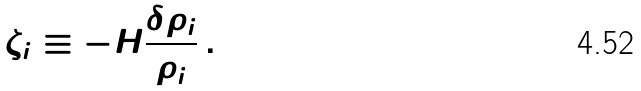Convert formula to latex. <formula><loc_0><loc_0><loc_500><loc_500>\zeta _ { i } \equiv - H \frac { \delta \rho _ { i } } { \dot { \rho } _ { i } } \, .</formula> 